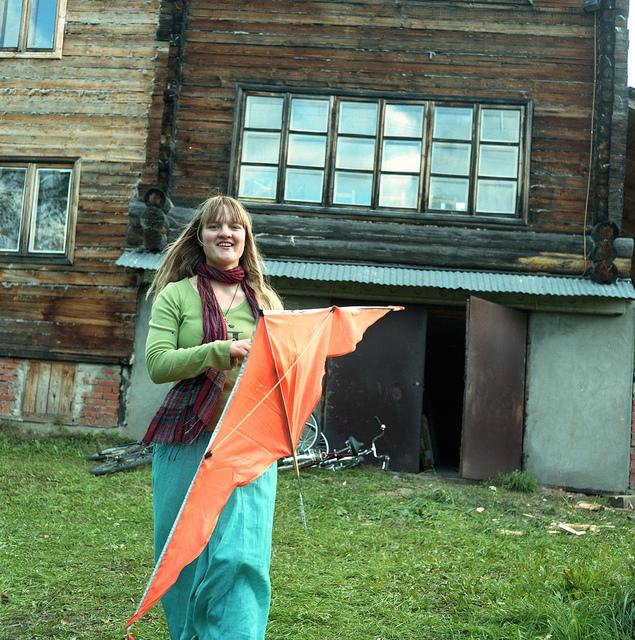Can an open door be seen?
Give a very brief answer. Yes. What is the girl holding?
Keep it brief. Kite. How many total panes are in the windows above the metal awning?
Quick response, please. 18. 